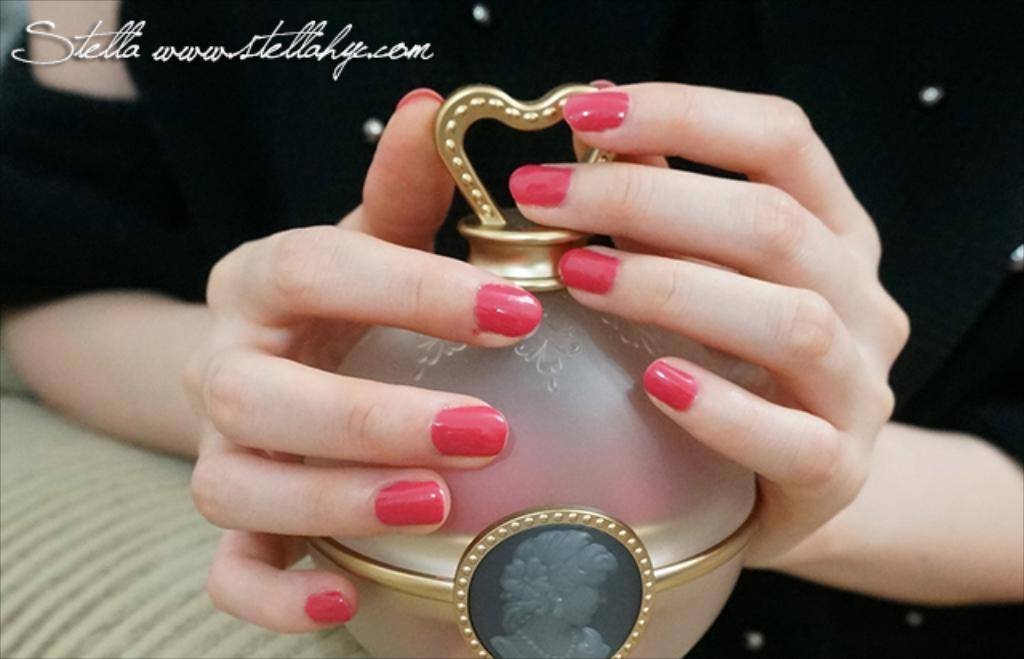Provide a one-sentence caption for the provided image. a perfume bottle next to a name that says Stella. 